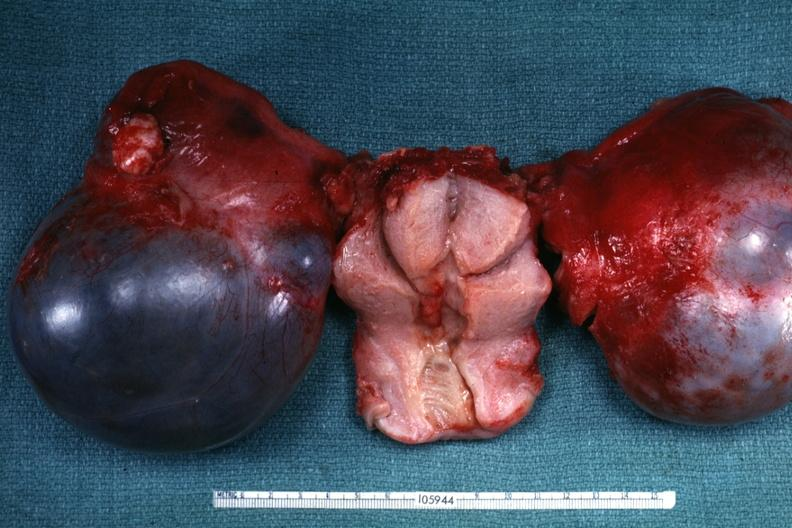what is external view of bilateral cystic ovarian tumors with uterus slide labeled cystadenocarcinoma malignancy?
Answer the question using a single word or phrase. Not obvious from gross appearance 